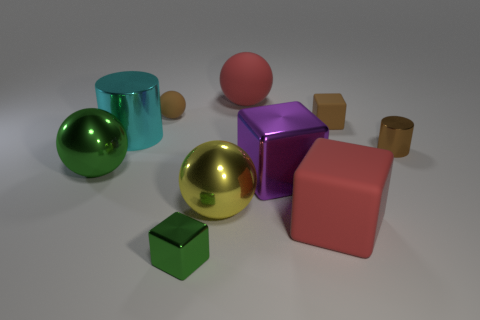Is the number of big blocks that are on the right side of the purple thing greater than the number of large spheres?
Provide a short and direct response. No. Are there any big matte balls that have the same color as the large matte cube?
Provide a short and direct response. Yes. There is a shiny cylinder that is the same size as the brown block; what is its color?
Offer a terse response. Brown. Are there the same number of purple metallic cylinders and small metallic cylinders?
Provide a short and direct response. No. How many tiny brown cylinders are behind the small shiny thing to the right of the tiny green shiny object?
Ensure brevity in your answer.  0. What number of things are either large cyan metal objects left of the yellow metal thing or metallic cylinders?
Provide a short and direct response. 2. How many red blocks have the same material as the big purple block?
Provide a short and direct response. 0. What is the shape of the rubber object that is the same color as the large matte block?
Your response must be concise. Sphere. Is the number of large objects right of the purple shiny object the same as the number of purple balls?
Keep it short and to the point. No. There is a metal object that is behind the small brown metal cylinder; what size is it?
Your response must be concise. Large. 